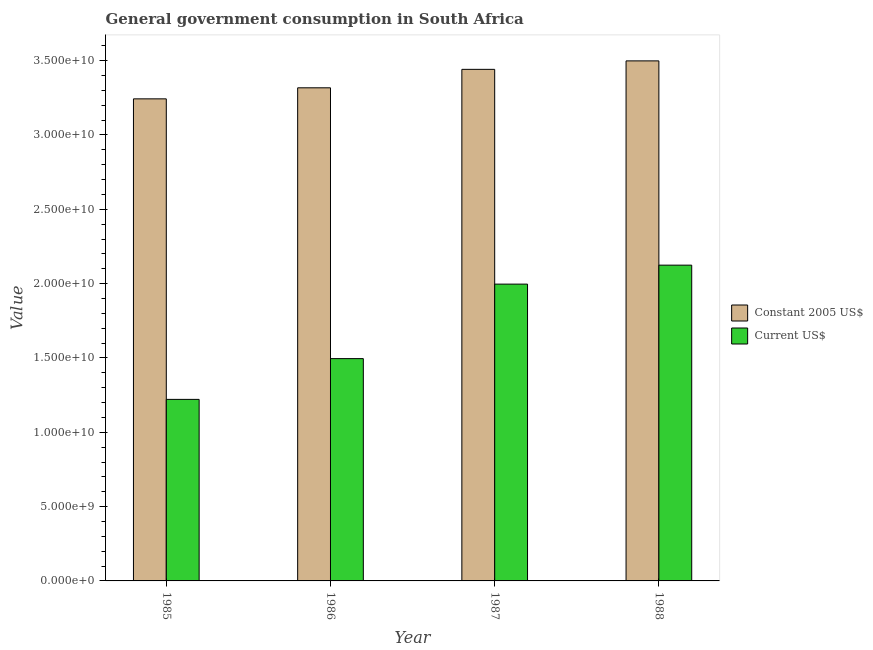How many different coloured bars are there?
Your response must be concise. 2. How many groups of bars are there?
Your response must be concise. 4. How many bars are there on the 3rd tick from the left?
Your response must be concise. 2. What is the label of the 3rd group of bars from the left?
Provide a succinct answer. 1987. What is the value consumed in constant 2005 us$ in 1987?
Your answer should be very brief. 3.44e+1. Across all years, what is the maximum value consumed in constant 2005 us$?
Make the answer very short. 3.50e+1. Across all years, what is the minimum value consumed in current us$?
Your answer should be compact. 1.22e+1. In which year was the value consumed in constant 2005 us$ maximum?
Keep it short and to the point. 1988. What is the total value consumed in constant 2005 us$ in the graph?
Keep it short and to the point. 1.35e+11. What is the difference between the value consumed in current us$ in 1985 and that in 1987?
Your answer should be very brief. -7.75e+09. What is the difference between the value consumed in current us$ in 1986 and the value consumed in constant 2005 us$ in 1988?
Your answer should be very brief. -6.29e+09. What is the average value consumed in constant 2005 us$ per year?
Your answer should be very brief. 3.38e+1. In the year 1985, what is the difference between the value consumed in constant 2005 us$ and value consumed in current us$?
Ensure brevity in your answer.  0. What is the ratio of the value consumed in constant 2005 us$ in 1985 to that in 1986?
Your response must be concise. 0.98. Is the value consumed in constant 2005 us$ in 1986 less than that in 1988?
Your answer should be compact. Yes. What is the difference between the highest and the second highest value consumed in constant 2005 us$?
Your response must be concise. 5.70e+08. What is the difference between the highest and the lowest value consumed in constant 2005 us$?
Your answer should be compact. 2.55e+09. In how many years, is the value consumed in constant 2005 us$ greater than the average value consumed in constant 2005 us$ taken over all years?
Make the answer very short. 2. What does the 1st bar from the left in 1988 represents?
Keep it short and to the point. Constant 2005 US$. What does the 1st bar from the right in 1986 represents?
Offer a very short reply. Current US$. How many bars are there?
Your answer should be compact. 8. How many years are there in the graph?
Make the answer very short. 4. How many legend labels are there?
Your answer should be compact. 2. What is the title of the graph?
Make the answer very short. General government consumption in South Africa. What is the label or title of the Y-axis?
Provide a succinct answer. Value. What is the Value in Constant 2005 US$ in 1985?
Make the answer very short. 3.24e+1. What is the Value in Current US$ in 1985?
Offer a very short reply. 1.22e+1. What is the Value in Constant 2005 US$ in 1986?
Give a very brief answer. 3.32e+1. What is the Value in Current US$ in 1986?
Offer a very short reply. 1.50e+1. What is the Value of Constant 2005 US$ in 1987?
Offer a very short reply. 3.44e+1. What is the Value in Current US$ in 1987?
Offer a terse response. 2.00e+1. What is the Value of Constant 2005 US$ in 1988?
Ensure brevity in your answer.  3.50e+1. What is the Value in Current US$ in 1988?
Your answer should be very brief. 2.12e+1. Across all years, what is the maximum Value of Constant 2005 US$?
Offer a terse response. 3.50e+1. Across all years, what is the maximum Value of Current US$?
Your answer should be compact. 2.12e+1. Across all years, what is the minimum Value of Constant 2005 US$?
Keep it short and to the point. 3.24e+1. Across all years, what is the minimum Value of Current US$?
Keep it short and to the point. 1.22e+1. What is the total Value in Constant 2005 US$ in the graph?
Make the answer very short. 1.35e+11. What is the total Value of Current US$ in the graph?
Make the answer very short. 6.84e+1. What is the difference between the Value of Constant 2005 US$ in 1985 and that in 1986?
Provide a short and direct response. -7.43e+08. What is the difference between the Value in Current US$ in 1985 and that in 1986?
Keep it short and to the point. -2.74e+09. What is the difference between the Value in Constant 2005 US$ in 1985 and that in 1987?
Your response must be concise. -1.98e+09. What is the difference between the Value of Current US$ in 1985 and that in 1987?
Offer a very short reply. -7.75e+09. What is the difference between the Value in Constant 2005 US$ in 1985 and that in 1988?
Ensure brevity in your answer.  -2.55e+09. What is the difference between the Value in Current US$ in 1985 and that in 1988?
Give a very brief answer. -9.03e+09. What is the difference between the Value in Constant 2005 US$ in 1986 and that in 1987?
Make the answer very short. -1.24e+09. What is the difference between the Value of Current US$ in 1986 and that in 1987?
Offer a very short reply. -5.01e+09. What is the difference between the Value in Constant 2005 US$ in 1986 and that in 1988?
Ensure brevity in your answer.  -1.81e+09. What is the difference between the Value in Current US$ in 1986 and that in 1988?
Your answer should be compact. -6.29e+09. What is the difference between the Value in Constant 2005 US$ in 1987 and that in 1988?
Keep it short and to the point. -5.70e+08. What is the difference between the Value of Current US$ in 1987 and that in 1988?
Provide a succinct answer. -1.28e+09. What is the difference between the Value of Constant 2005 US$ in 1985 and the Value of Current US$ in 1986?
Your answer should be compact. 1.75e+1. What is the difference between the Value in Constant 2005 US$ in 1985 and the Value in Current US$ in 1987?
Make the answer very short. 1.25e+1. What is the difference between the Value in Constant 2005 US$ in 1985 and the Value in Current US$ in 1988?
Provide a succinct answer. 1.12e+1. What is the difference between the Value of Constant 2005 US$ in 1986 and the Value of Current US$ in 1987?
Keep it short and to the point. 1.32e+1. What is the difference between the Value of Constant 2005 US$ in 1986 and the Value of Current US$ in 1988?
Ensure brevity in your answer.  1.19e+1. What is the difference between the Value of Constant 2005 US$ in 1987 and the Value of Current US$ in 1988?
Make the answer very short. 1.32e+1. What is the average Value in Constant 2005 US$ per year?
Provide a short and direct response. 3.38e+1. What is the average Value in Current US$ per year?
Your answer should be very brief. 1.71e+1. In the year 1985, what is the difference between the Value in Constant 2005 US$ and Value in Current US$?
Offer a very short reply. 2.02e+1. In the year 1986, what is the difference between the Value of Constant 2005 US$ and Value of Current US$?
Keep it short and to the point. 1.82e+1. In the year 1987, what is the difference between the Value in Constant 2005 US$ and Value in Current US$?
Offer a very short reply. 1.44e+1. In the year 1988, what is the difference between the Value of Constant 2005 US$ and Value of Current US$?
Your answer should be very brief. 1.37e+1. What is the ratio of the Value of Constant 2005 US$ in 1985 to that in 1986?
Give a very brief answer. 0.98. What is the ratio of the Value of Current US$ in 1985 to that in 1986?
Your answer should be very brief. 0.82. What is the ratio of the Value in Constant 2005 US$ in 1985 to that in 1987?
Make the answer very short. 0.94. What is the ratio of the Value in Current US$ in 1985 to that in 1987?
Your answer should be very brief. 0.61. What is the ratio of the Value in Constant 2005 US$ in 1985 to that in 1988?
Your response must be concise. 0.93. What is the ratio of the Value in Current US$ in 1985 to that in 1988?
Give a very brief answer. 0.57. What is the ratio of the Value of Constant 2005 US$ in 1986 to that in 1987?
Keep it short and to the point. 0.96. What is the ratio of the Value of Current US$ in 1986 to that in 1987?
Your answer should be very brief. 0.75. What is the ratio of the Value of Constant 2005 US$ in 1986 to that in 1988?
Provide a short and direct response. 0.95. What is the ratio of the Value in Current US$ in 1986 to that in 1988?
Your response must be concise. 0.7. What is the ratio of the Value in Constant 2005 US$ in 1987 to that in 1988?
Provide a succinct answer. 0.98. What is the ratio of the Value of Current US$ in 1987 to that in 1988?
Your answer should be compact. 0.94. What is the difference between the highest and the second highest Value of Constant 2005 US$?
Your answer should be compact. 5.70e+08. What is the difference between the highest and the second highest Value in Current US$?
Offer a terse response. 1.28e+09. What is the difference between the highest and the lowest Value of Constant 2005 US$?
Offer a terse response. 2.55e+09. What is the difference between the highest and the lowest Value in Current US$?
Your answer should be very brief. 9.03e+09. 